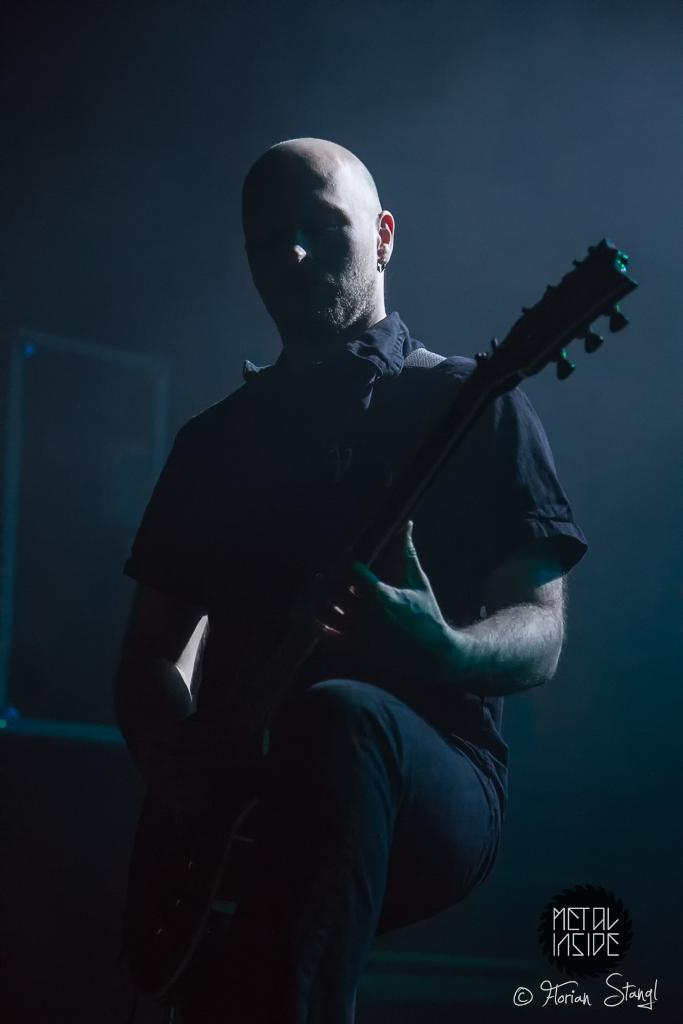What is the main subject of the image? There is a man in the image. What is the man holding in the image? The man is holding a guitar. How many cast members are visible in the image? There are no cast members present in the image, as it only features a man holding a guitar. What type of boats can be seen in the image? There are no boats present in the image; it only features a man holding a guitar. 